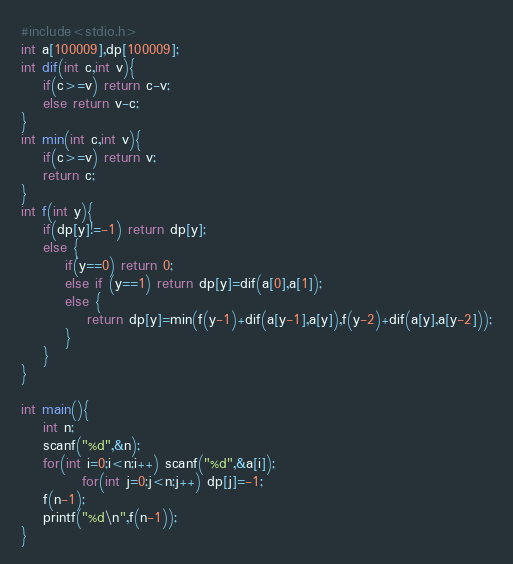Convert code to text. <code><loc_0><loc_0><loc_500><loc_500><_C_>#include<stdio.h>
int a[100009],dp[100009];
int dif(int c,int v){
	if(c>=v) return c-v;
	else return v-c;
}
int min(int c,int v){
	if(c>=v) return v;
	return c;
}
int f(int y){
	if(dp[y]!=-1) return dp[y];
	else {
		if(y==0) return 0;
		else if (y==1) return dp[y]=dif(a[0],a[1]);
		else {
			return dp[y]=min(f(y-1)+dif(a[y-1],a[y]),f(y-2)+dif(a[y],a[y-2]));
		}
	}
}

int main(){
	int n;
	scanf("%d",&n);
	for(int i=0;i<n;i++) scanf("%d",&a[i]);
	       for(int j=0;j<n;j++) dp[j]=-1;
	f(n-1);
	printf("%d\n",f(n-1));
}
</code> 